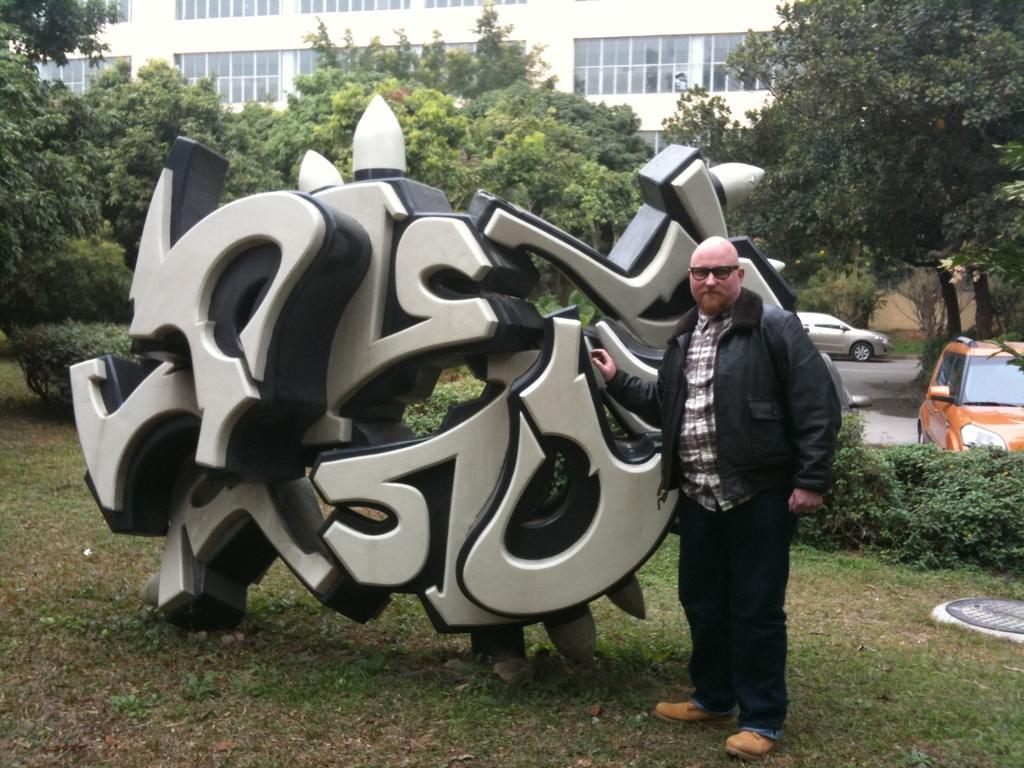Please provide a concise description of this image. In this picture we can see a carving architecture on the grass, beside to it we can find a man, in the background we can see trees, buildings and cars. 